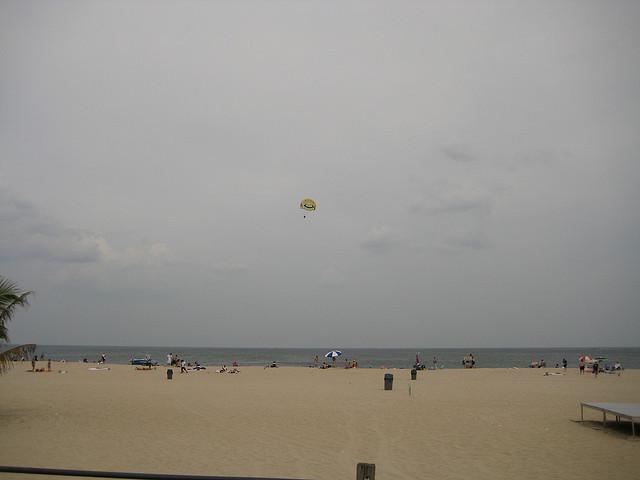Is the camera being held with correct orientation to the horizon?
Write a very short answer. Yes. Is visibility very clear?
Quick response, please. No. How many scenes are in the image?
Be succinct. 1. Why is this attractive to dogs?
Write a very short answer. Room to run. Is there a kite in the sky?
Concise answer only. Yes. What is in the sky?
Keep it brief. Kite. How many umbrellas are there?
Answer briefly. 2. Do you see a bike?
Answer briefly. No. How many umbrella's are shown?
Give a very brief answer. 2. Is this a Photoshopped photo?
Keep it brief. No. What is covering the ground?
Keep it brief. Sand. Where was this picture taken?
Concise answer only. Beach. How sun blocking items stuck in the sand?
Short answer required. Umbrella. What is flying in the air?
Quick response, please. Kite. Is there a glimmer of the lights of a  skyline from the bench?
Answer briefly. No. How many people are in the photo?
Write a very short answer. 20. Where is the picture taken at?
Give a very brief answer. Beach. What is flying in the sky?
Give a very brief answer. Kite. Who made this?
Concise answer only. Photographer. How many parasailers are there?
Write a very short answer. 1. Is it hot on this beach?
Short answer required. Yes. Is this a bright and sunny day?
Answer briefly. No. Was this picture taken at near mid day?
Concise answer only. Yes. What did he jump off of?
Keep it brief. Plane. Is it cold?
Short answer required. No. What color is the kite?
Keep it brief. Yellow. What place is this picture taken?
Answer briefly. Beach. Is there a tower on this picture?
Keep it brief. No. Is there a flag on the beach?
Write a very short answer. No. Is there any waves in the beach?
Concise answer only. No. 